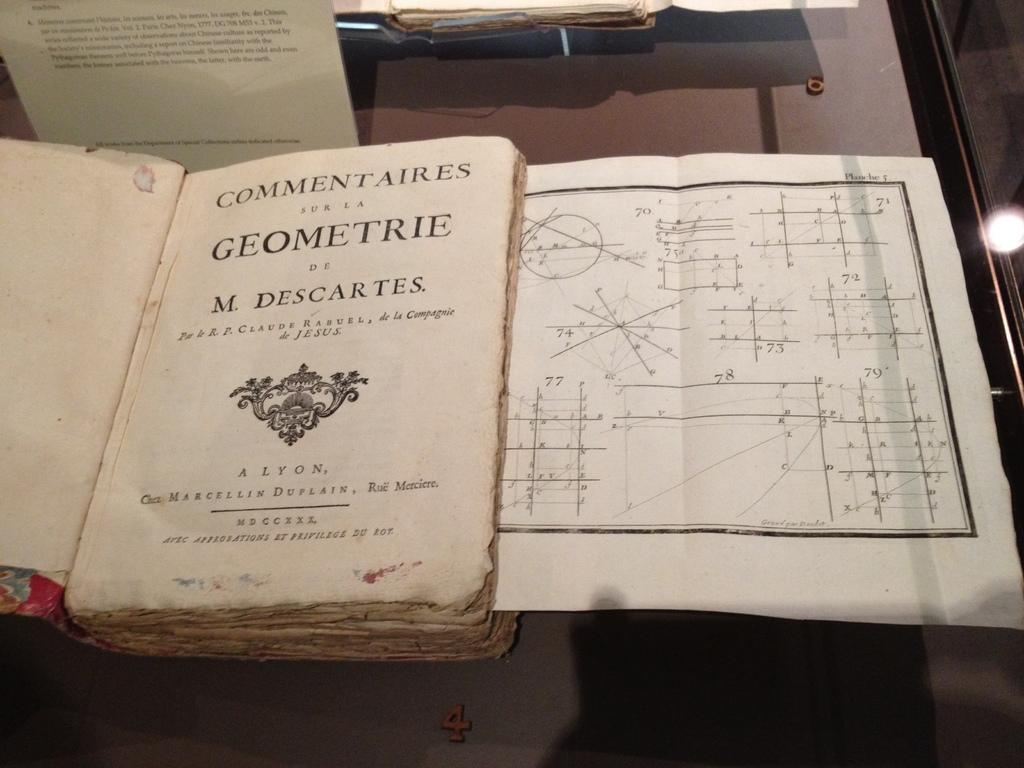<image>
Present a compact description of the photo's key features. A very old book entitled Geometrie by M. Descartes. 